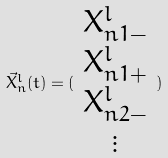Convert formula to latex. <formula><loc_0><loc_0><loc_500><loc_500>\vec { X } _ { n } ^ { l } ( t ) = ( \begin{array} { c } X _ { n 1 - } ^ { l } \\ X _ { n 1 + } ^ { l } \\ X _ { n 2 - } ^ { l } \\ \vdots \end{array} )</formula> 